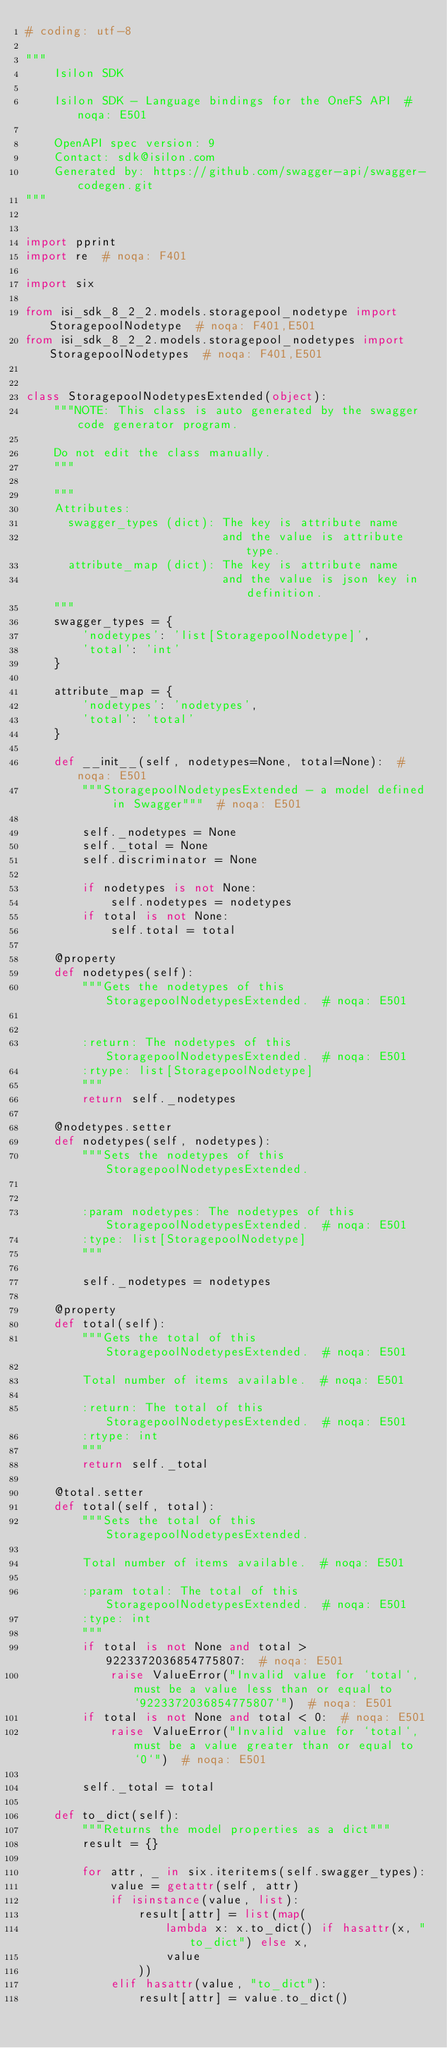Convert code to text. <code><loc_0><loc_0><loc_500><loc_500><_Python_># coding: utf-8

"""
    Isilon SDK

    Isilon SDK - Language bindings for the OneFS API  # noqa: E501

    OpenAPI spec version: 9
    Contact: sdk@isilon.com
    Generated by: https://github.com/swagger-api/swagger-codegen.git
"""


import pprint
import re  # noqa: F401

import six

from isi_sdk_8_2_2.models.storagepool_nodetype import StoragepoolNodetype  # noqa: F401,E501
from isi_sdk_8_2_2.models.storagepool_nodetypes import StoragepoolNodetypes  # noqa: F401,E501


class StoragepoolNodetypesExtended(object):
    """NOTE: This class is auto generated by the swagger code generator program.

    Do not edit the class manually.
    """

    """
    Attributes:
      swagger_types (dict): The key is attribute name
                            and the value is attribute type.
      attribute_map (dict): The key is attribute name
                            and the value is json key in definition.
    """
    swagger_types = {
        'nodetypes': 'list[StoragepoolNodetype]',
        'total': 'int'
    }

    attribute_map = {
        'nodetypes': 'nodetypes',
        'total': 'total'
    }

    def __init__(self, nodetypes=None, total=None):  # noqa: E501
        """StoragepoolNodetypesExtended - a model defined in Swagger"""  # noqa: E501

        self._nodetypes = None
        self._total = None
        self.discriminator = None

        if nodetypes is not None:
            self.nodetypes = nodetypes
        if total is not None:
            self.total = total

    @property
    def nodetypes(self):
        """Gets the nodetypes of this StoragepoolNodetypesExtended.  # noqa: E501


        :return: The nodetypes of this StoragepoolNodetypesExtended.  # noqa: E501
        :rtype: list[StoragepoolNodetype]
        """
        return self._nodetypes

    @nodetypes.setter
    def nodetypes(self, nodetypes):
        """Sets the nodetypes of this StoragepoolNodetypesExtended.


        :param nodetypes: The nodetypes of this StoragepoolNodetypesExtended.  # noqa: E501
        :type: list[StoragepoolNodetype]
        """

        self._nodetypes = nodetypes

    @property
    def total(self):
        """Gets the total of this StoragepoolNodetypesExtended.  # noqa: E501

        Total number of items available.  # noqa: E501

        :return: The total of this StoragepoolNodetypesExtended.  # noqa: E501
        :rtype: int
        """
        return self._total

    @total.setter
    def total(self, total):
        """Sets the total of this StoragepoolNodetypesExtended.

        Total number of items available.  # noqa: E501

        :param total: The total of this StoragepoolNodetypesExtended.  # noqa: E501
        :type: int
        """
        if total is not None and total > 9223372036854775807:  # noqa: E501
            raise ValueError("Invalid value for `total`, must be a value less than or equal to `9223372036854775807`")  # noqa: E501
        if total is not None and total < 0:  # noqa: E501
            raise ValueError("Invalid value for `total`, must be a value greater than or equal to `0`")  # noqa: E501

        self._total = total

    def to_dict(self):
        """Returns the model properties as a dict"""
        result = {}

        for attr, _ in six.iteritems(self.swagger_types):
            value = getattr(self, attr)
            if isinstance(value, list):
                result[attr] = list(map(
                    lambda x: x.to_dict() if hasattr(x, "to_dict") else x,
                    value
                ))
            elif hasattr(value, "to_dict"):
                result[attr] = value.to_dict()</code> 